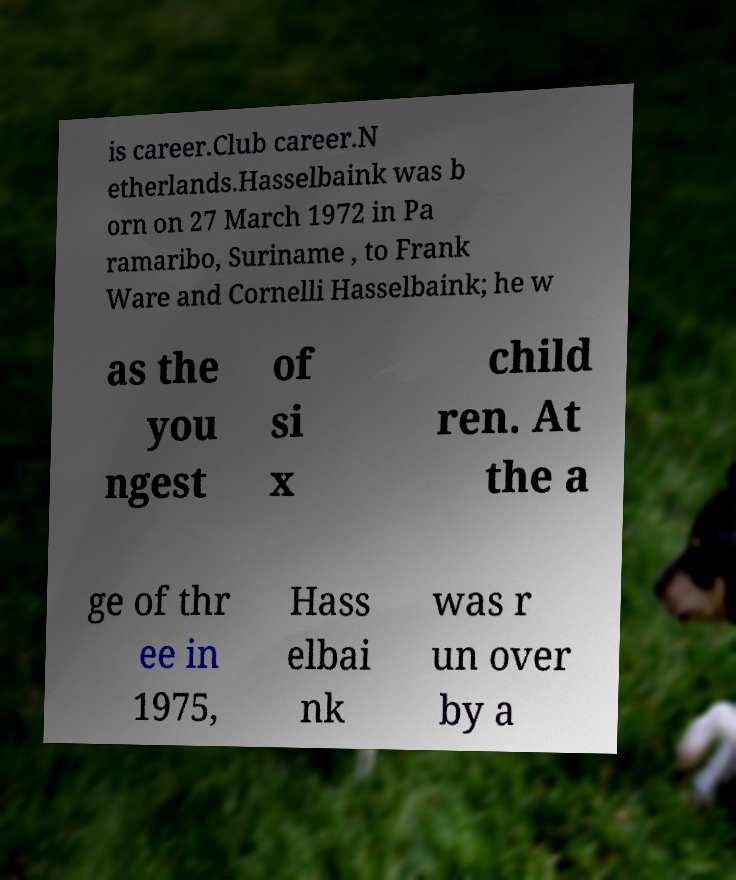Please read and relay the text visible in this image. What does it say? is career.Club career.N etherlands.Hasselbaink was b orn on 27 March 1972 in Pa ramaribo, Suriname , to Frank Ware and Cornelli Hasselbaink; he w as the you ngest of si x child ren. At the a ge of thr ee in 1975, Hass elbai nk was r un over by a 